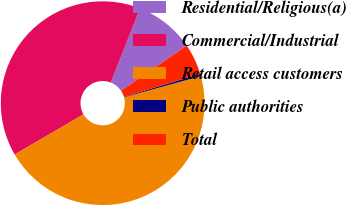Convert chart. <chart><loc_0><loc_0><loc_500><loc_500><pie_chart><fcel>Residential/Religious(a)<fcel>Commercial/Industrial<fcel>Retail access customers<fcel>Public authorities<fcel>Total<nl><fcel>9.47%<fcel>39.38%<fcel>45.88%<fcel>0.36%<fcel>4.91%<nl></chart> 